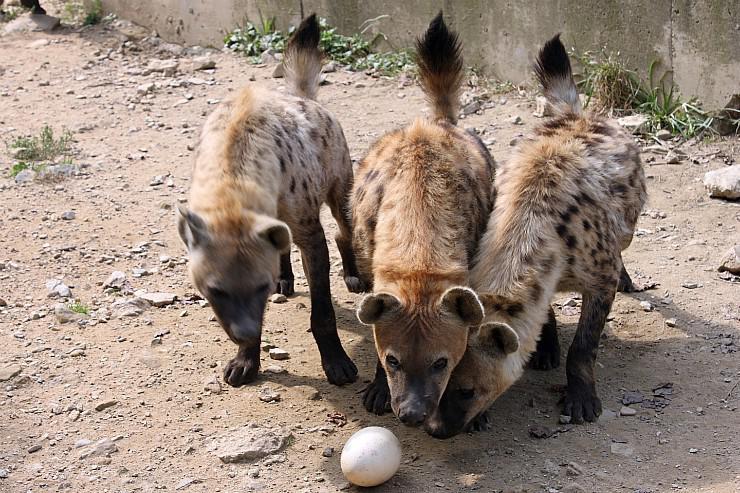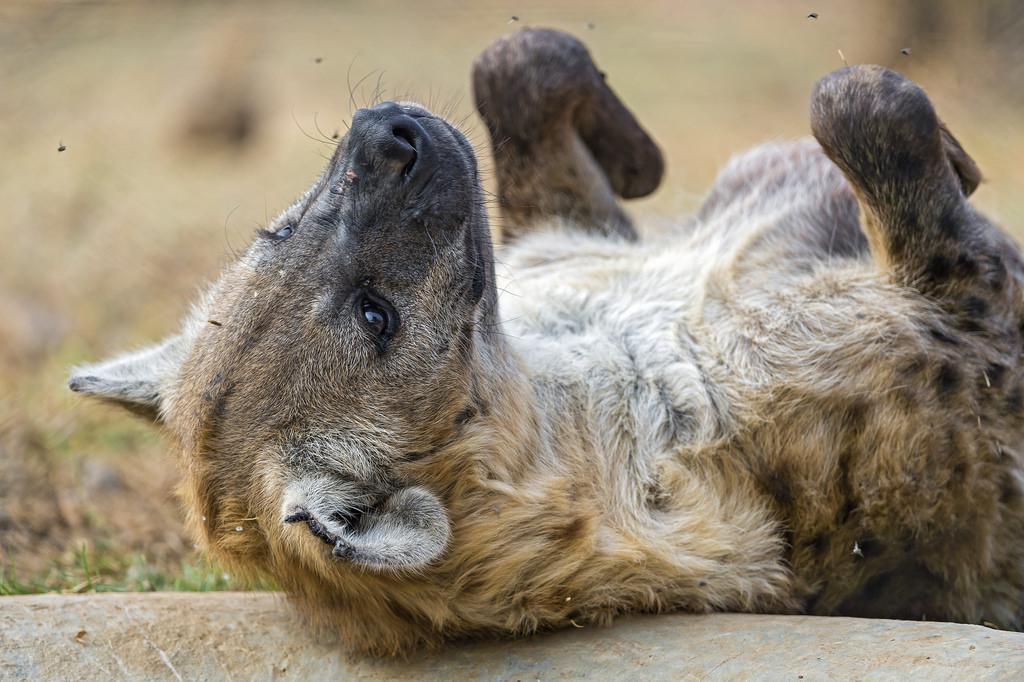The first image is the image on the left, the second image is the image on the right. Evaluate the accuracy of this statement regarding the images: "There are four hyenas.". Is it true? Answer yes or no. Yes. The first image is the image on the left, the second image is the image on the right. Examine the images to the left and right. Is the description "The lefthand image includes multiple hyenas, and at least one hyena stands with its nose bent to the ground." accurate? Answer yes or no. Yes. 